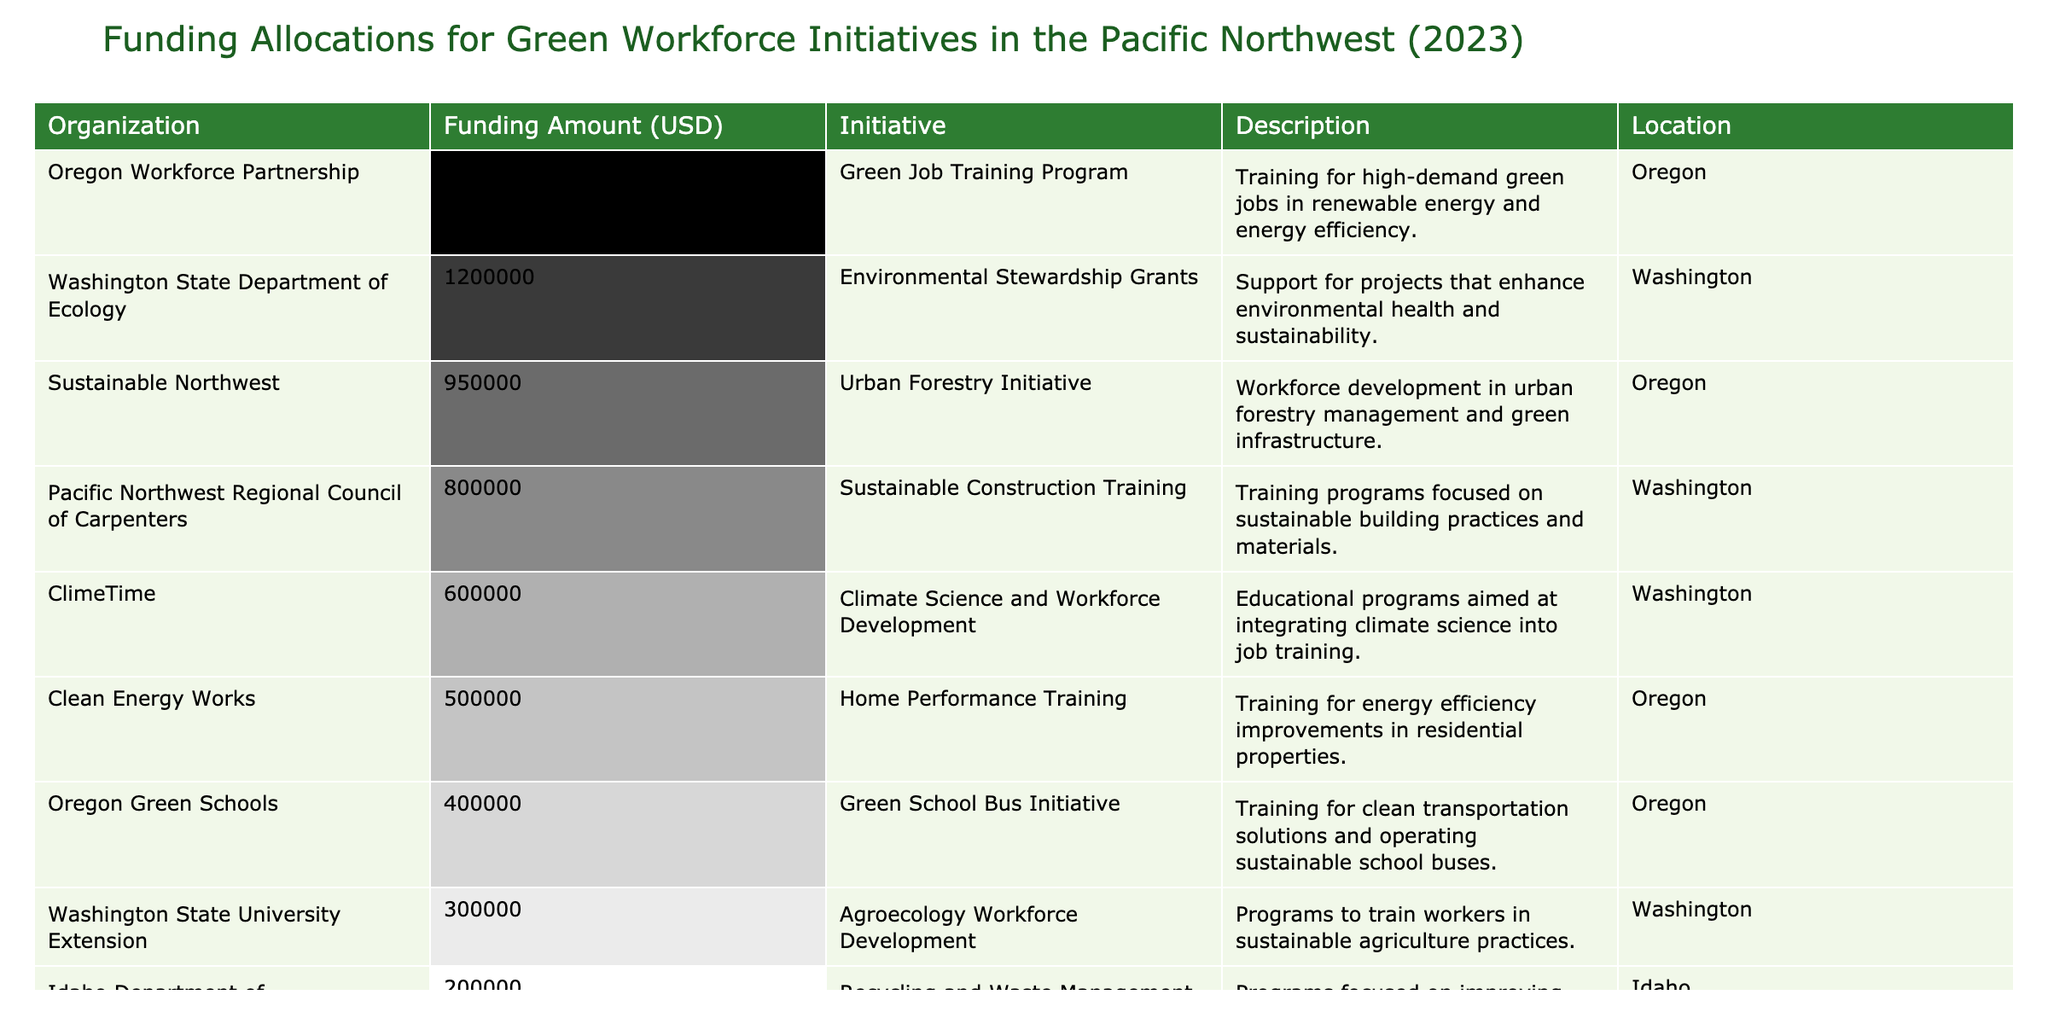What is the funding amount for the Oregon Workforce Partnership? The table shows that the funding amount for the Oregon Workforce Partnership is listed directly in the table. By locating the row for this organization, I can see the value is 1,500,000 USD.
Answer: 1,500,000 USD Which organization received the least funding? Upon reviewing the table, I can see that the Idaho Department of Environmental Quality has the lowest funding amount at 200,000 USD.
Answer: Idaho Department of Environmental Quality What is the total funding allocated to initiatives in Washington? To find the total funding for Washington, I add up the funding amounts from organizations located in Washington: 1,200,000 (Department of Ecology) + 800,000 (Council of Carpenters) + 600,000 (ClimeTime) + 300,000 (WSU Extension) = 2,900,000 USD.
Answer: 2,900,000 USD Is the funding for the Sustainable Northwest higher than the funding for Clean Energy Works? By comparing the funding amounts, I see Sustainable Northwest received 950,000 USD, while Clean Energy Works received 500,000 USD. Since 950,000 is greater than 500,000, the statement is true.
Answer: Yes What is the average funding amount for organizations based in Oregon? The organizations in Oregon and their funding amounts are: Oregon Workforce Partnership (1,500,000), Sustainable Northwest (950,000), Oregon Green Schools (400,000), and Clean Energy Works (500,000). Adding these amounts gives 3,350,000 USD. There are four organizations, so I divide: 3,350,000 / 4 = 837,500.
Answer: 837,500 USD How much funding is allocated to environmental stewardship initiatives in Washington? Looking at the table, the Washington State Department of Ecology allocates 1,200,000 USD, which supports environmental stewardship. There are no other environmental stewardship initiatives listed for Washington.
Answer: 1,200,000 USD Do any organizations in Idaho have funding amounts greater than 300,000 USD? Examining the table reveals that the only listed organization in Idaho is the Idaho Department of Environmental Quality with a funding amount of 200,000 USD, which is less than 300,000 USD. Therefore, no organizations in Idaho exceed that amount.
Answer: No What is the difference between the funding amounts for Oregon's Green Job Training Program and the Urban Forestry Initiative? The Oregon’s Green Job Training Program has a funding of 1,500,000 USD and the Urban Forestry Initiative has 950,000 USD. The difference is calculated as 1,500,000 - 950,000 = 550,000 USD.
Answer: 550,000 USD Which initiative has the highest allocation, and by how much does it exceed the second highest? The initiative with the highest allocation is Oregon Workforce Partnership with 1,500,000 USD. The second highest is Washington State Department of Ecology with 1,200,000 USD. The difference is 1,500,000 - 1,200,000 = 300,000 USD.
Answer: 300,000 USD What proportion of the total funding across all organizations is allocated to the Climate Science and Workforce Development initiative? First, I sum all the funding amounts to find the total: 1,500,000 + 1,200,000 + 800,000 + 950,000 + 600,000 + 400,000 + 200,000 + 500,000 + 300,000 = 5,600,000 USD. The funding for the Climate Science initiative is 600,000 USD. The proportion is calculated as 600,000 / 5,600,000 = 0.1071 or approximately 10.71%.
Answer: 10.71% 